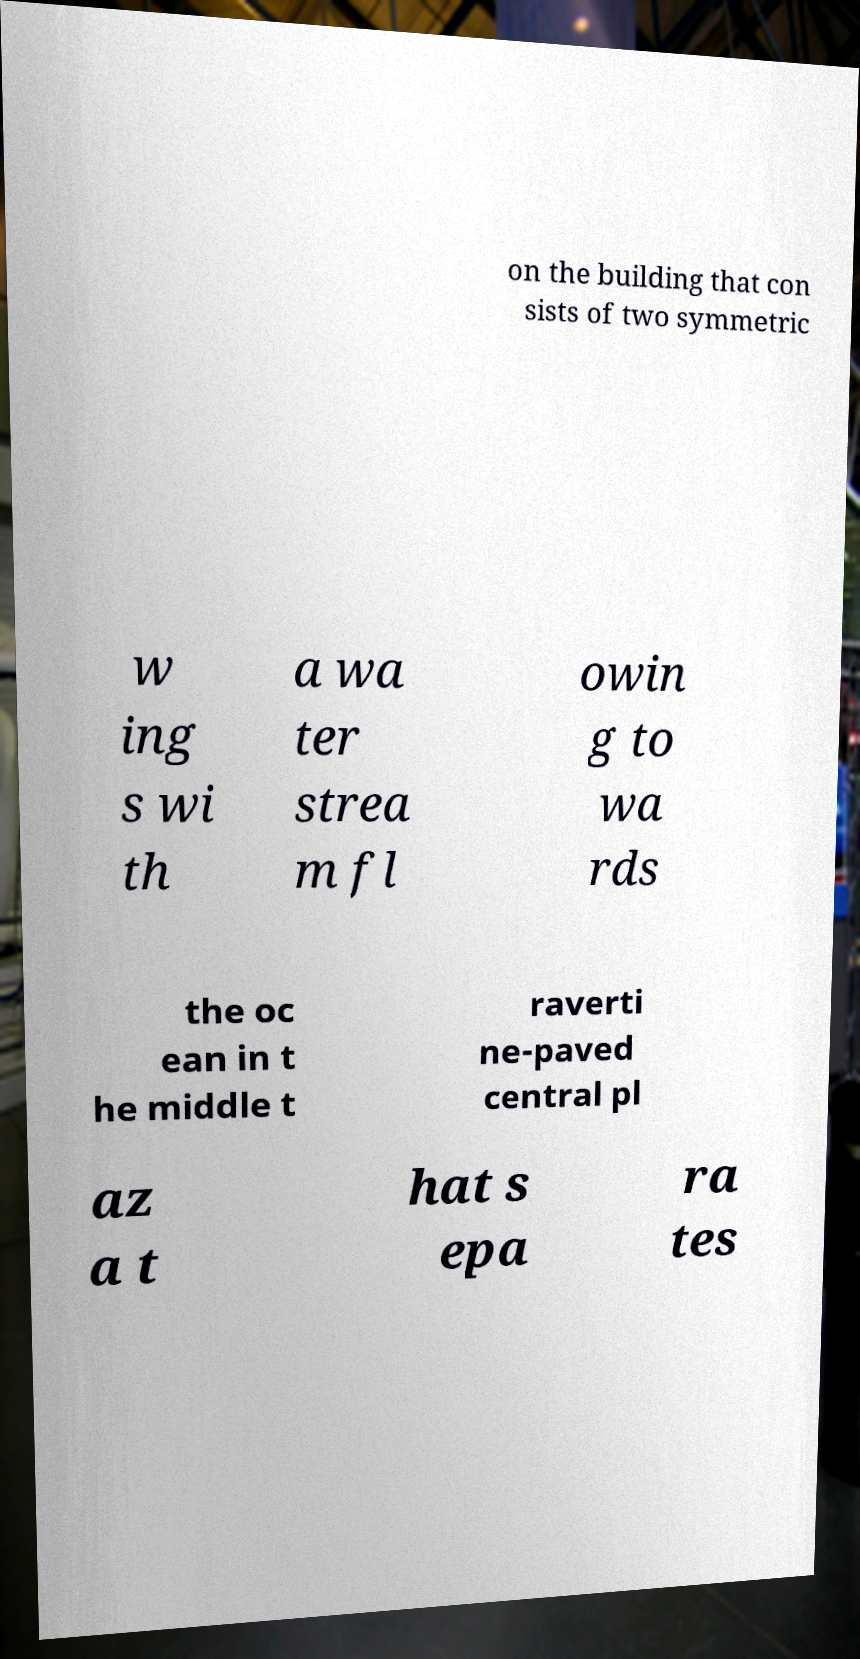Could you assist in decoding the text presented in this image and type it out clearly? on the building that con sists of two symmetric w ing s wi th a wa ter strea m fl owin g to wa rds the oc ean in t he middle t raverti ne-paved central pl az a t hat s epa ra tes 